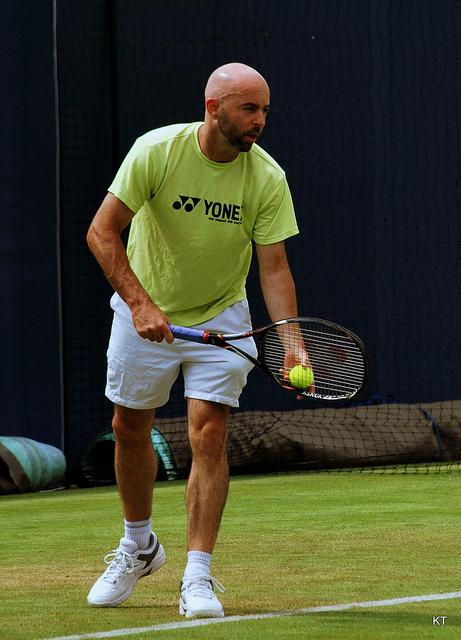What tennis player is this?
Concise answer only. Andre agassi. Is the man bald?
Concise answer only. Yes. What color is his shirt?
Write a very short answer. Yellow. What game is being played?
Keep it brief. Tennis. What is the color of the ball?
Quick response, please. Yellow. Is this man wearing anything that is not white?
Give a very brief answer. Yes. What is this game?
Short answer required. Tennis. What color is his outfit?
Concise answer only. Green and white. What color is the man's shirt?
Answer briefly. Yellow. 